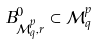Convert formula to latex. <formula><loc_0><loc_0><loc_500><loc_500>B ^ { 0 } _ { \mathcal { M } ^ { p } _ { q } , r } \subset \mathcal { M } ^ { p } _ { q }</formula> 